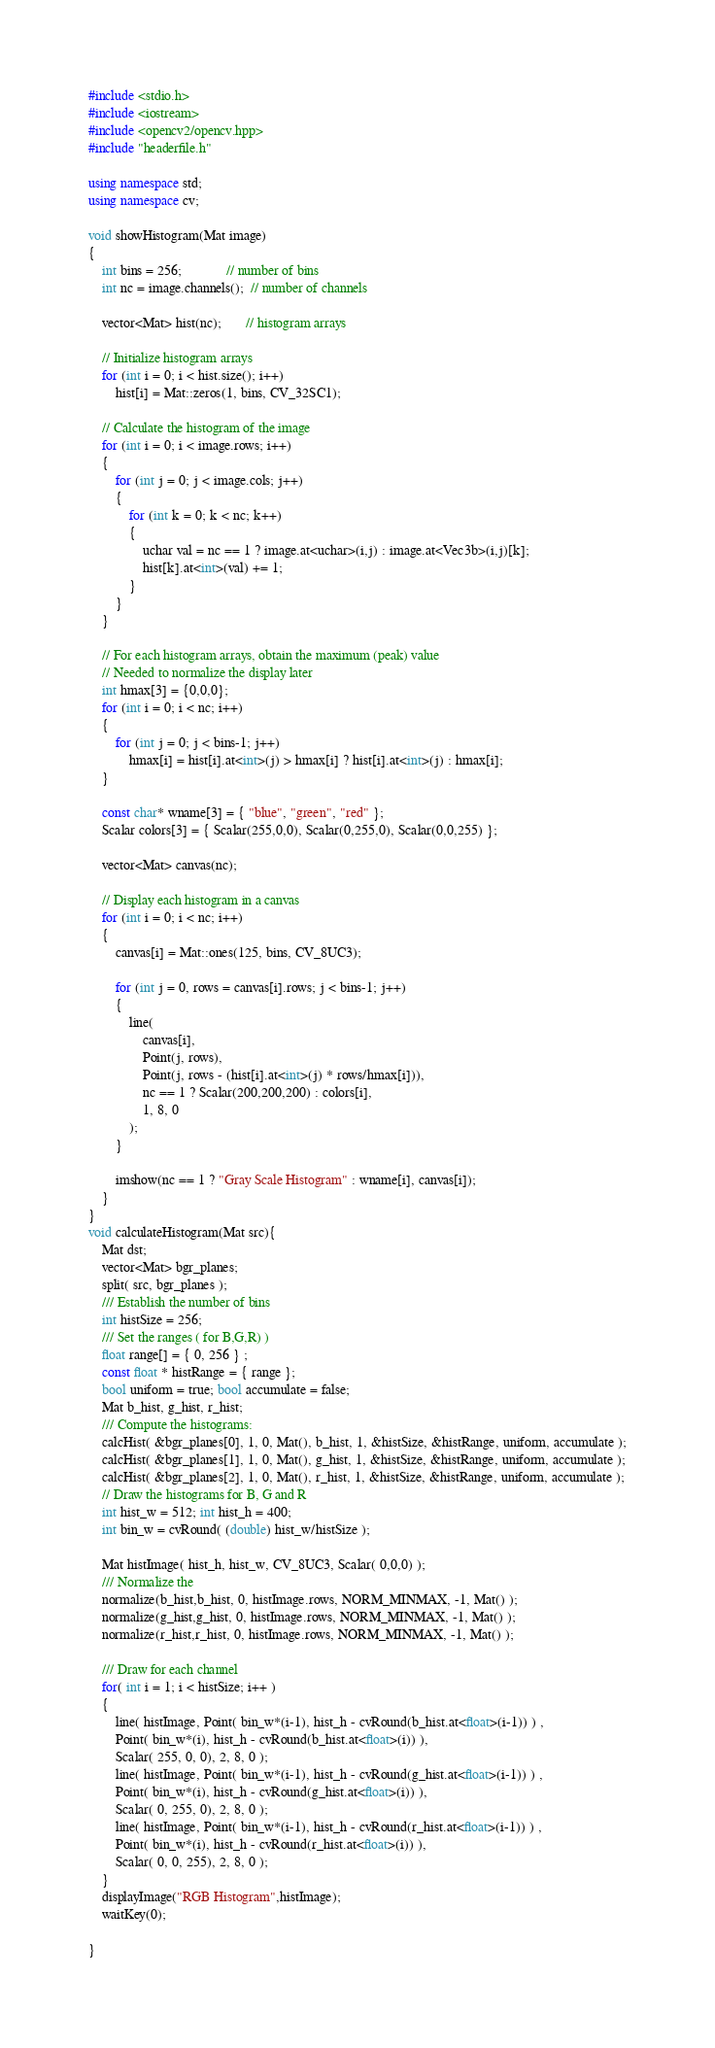Convert code to text. <code><loc_0><loc_0><loc_500><loc_500><_C++_>#include <stdio.h>
#include <iostream>
#include <opencv2/opencv.hpp>
#include "headerfile.h"

using namespace std;
using namespace cv;

void showHistogram(Mat image)
{
	int bins = 256;             // number of bins
	int nc = image.channels();  // number of channels

	vector<Mat> hist(nc);       // histogram arrays

	// Initialize histogram arrays
	for (int i = 0; i < hist.size(); i++)
		hist[i] = Mat::zeros(1, bins, CV_32SC1);

	// Calculate the histogram of the image
	for (int i = 0; i < image.rows; i++)
	{
		for (int j = 0; j < image.cols; j++)
		{
			for (int k = 0; k < nc; k++)
			{
				uchar val = nc == 1 ? image.at<uchar>(i,j) : image.at<Vec3b>(i,j)[k];
				hist[k].at<int>(val) += 1;
			}
		}
	}

	// For each histogram arrays, obtain the maximum (peak) value
	// Needed to normalize the display later
	int hmax[3] = {0,0,0};
	for (int i = 0; i < nc; i++)
	{
		for (int j = 0; j < bins-1; j++)
			hmax[i] = hist[i].at<int>(j) > hmax[i] ? hist[i].at<int>(j) : hmax[i];
	}

	const char* wname[3] = { "blue", "green", "red" };
	Scalar colors[3] = { Scalar(255,0,0), Scalar(0,255,0), Scalar(0,0,255) };

	vector<Mat> canvas(nc);

	// Display each histogram in a canvas
	for (int i = 0; i < nc; i++)
	{
		canvas[i] = Mat::ones(125, bins, CV_8UC3);

		for (int j = 0, rows = canvas[i].rows; j < bins-1; j++)
		{
			line(
				canvas[i],
				Point(j, rows),
				Point(j, rows - (hist[i].at<int>(j) * rows/hmax[i])),
				nc == 1 ? Scalar(200,200,200) : colors[i],
				1, 8, 0
			);
		}

		imshow(nc == 1 ? "Gray Scale Histogram" : wname[i], canvas[i]);
	}
}
void calculateHistogram(Mat src){
	Mat dst;
	vector<Mat> bgr_planes;
	split( src, bgr_planes );
	/// Establish the number of bins
	int histSize = 256;
	/// Set the ranges ( for B,G,R) )
	float range[] = { 0, 256 } ;
	const float * histRange = { range };
	bool uniform = true; bool accumulate = false;
	Mat b_hist, g_hist, r_hist;
	/// Compute the histograms:
	calcHist( &bgr_planes[0], 1, 0, Mat(), b_hist, 1, &histSize, &histRange, uniform, accumulate );
	calcHist( &bgr_planes[1], 1, 0, Mat(), g_hist, 1, &histSize, &histRange, uniform, accumulate );
	calcHist( &bgr_planes[2], 1, 0, Mat(), r_hist, 1, &histSize, &histRange, uniform, accumulate );
	// Draw the histograms for B, G and R
	int hist_w = 512; int hist_h = 400;
	int bin_w = cvRound( (double) hist_w/histSize );

	Mat histImage( hist_h, hist_w, CV_8UC3, Scalar( 0,0,0) );
	/// Normalize the
	normalize(b_hist,b_hist, 0, histImage.rows, NORM_MINMAX, -1, Mat() );
	normalize(g_hist,g_hist, 0, histImage.rows, NORM_MINMAX, -1, Mat() );
	normalize(r_hist,r_hist, 0, histImage.rows, NORM_MINMAX, -1, Mat() );

	/// Draw for each channel
	for( int i = 1; i < histSize; i++ )
	{
		line( histImage, Point( bin_w*(i-1), hist_h - cvRound(b_hist.at<float>(i-1)) ) ,
		Point( bin_w*(i), hist_h - cvRound(b_hist.at<float>(i)) ),
		Scalar( 255, 0, 0), 2, 8, 0 );
		line( histImage, Point( bin_w*(i-1), hist_h - cvRound(g_hist.at<float>(i-1)) ) ,
		Point( bin_w*(i), hist_h - cvRound(g_hist.at<float>(i)) ),
		Scalar( 0, 255, 0), 2, 8, 0 );
		line( histImage, Point( bin_w*(i-1), hist_h - cvRound(r_hist.at<float>(i-1)) ) ,
		Point( bin_w*(i), hist_h - cvRound(r_hist.at<float>(i)) ),
		Scalar( 0, 0, 255), 2, 8, 0 );
	}
	displayImage("RGB Histogram",histImage);
    waitKey(0);

}
</code> 